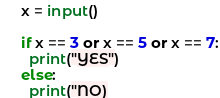<code> <loc_0><loc_0><loc_500><loc_500><_Python_>
x = input()

if x == 3 or x == 5 or x == 7:
  print("YES")
else:
  print("NO)</code> 